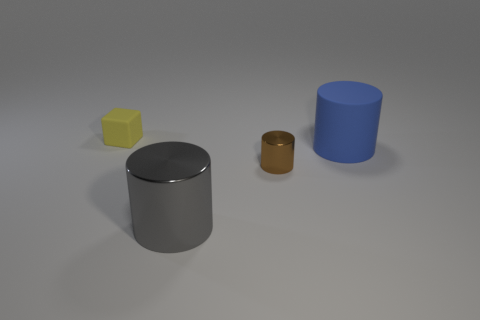Add 1 big purple matte objects. How many objects exist? 5 Subtract all cylinders. How many objects are left? 1 Subtract all small blocks. Subtract all large yellow rubber balls. How many objects are left? 3 Add 4 big shiny objects. How many big shiny objects are left? 5 Add 3 small gray matte blocks. How many small gray matte blocks exist? 3 Subtract 1 brown cylinders. How many objects are left? 3 